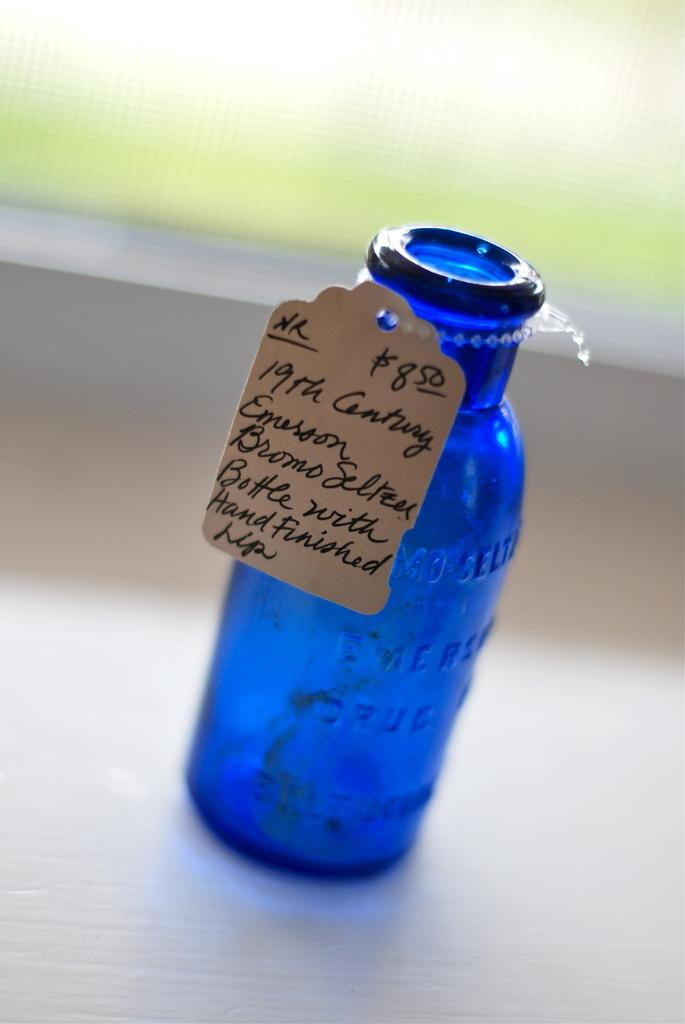<image>
Relay a brief, clear account of the picture shown. A blue bottle says "19th Century Emerson Bromo Seltzer". 